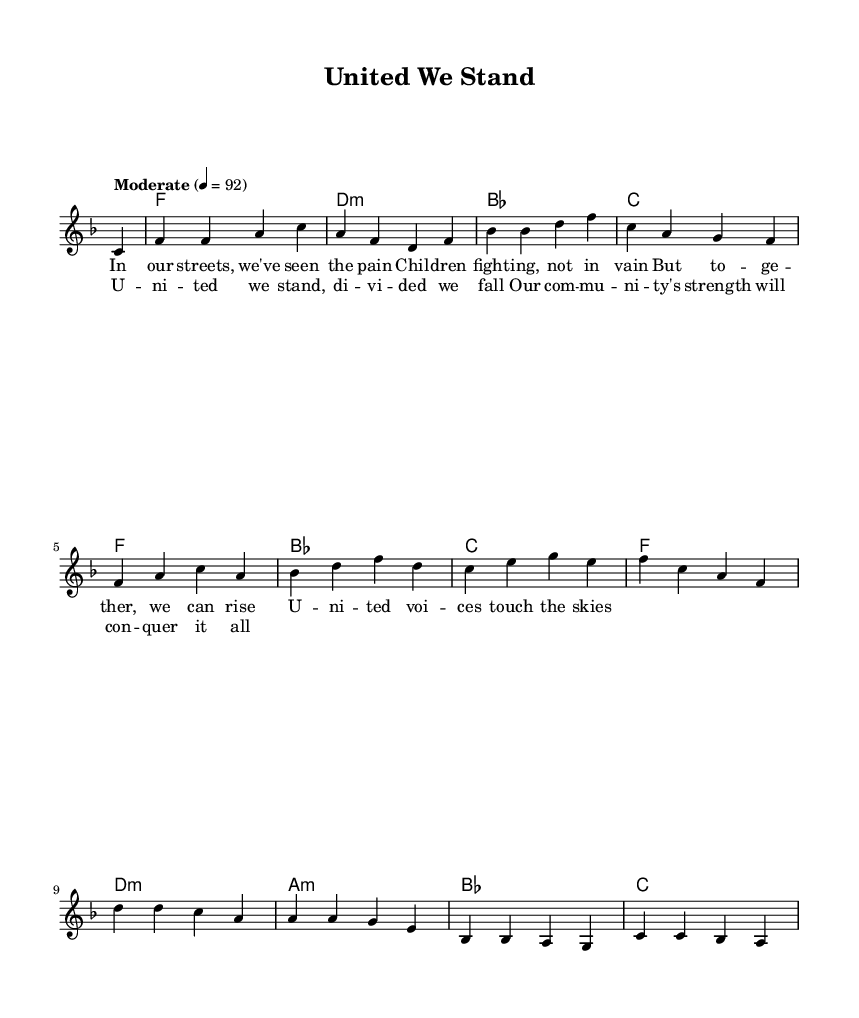What is the key signature of this music? The key signature is F major, which has one flat (B flat). This is evident from the key indication at the beginning of the staff, marked by the 'F' one line above the staff.
Answer: F major What is the time signature of this music? The time signature is 4/4, which signifies that there are four beats in a measure and the quarter note receives one beat. This can be observed at the beginning of the score, next to the key signature.
Answer: 4/4 What is the tempo marking for this piece? The tempo marking is "Moderate," indicated at the start of the score with a metronome marking of 92 beats per minute. This shows the intended pace of the music.
Answer: Moderate How many measures are in the verse section? There are four measures in the verse section, as indicated by the four lines of lyrics. Each line corresponds to one measure, as shown in the melody notation.
Answer: 4 What is the main theme of the chorus lyrics? The main theme of the chorus emphasizes unity and community strength, as highlighted in phrases like "united we stand, divided we fall." This reflects the song's message of togetherness.
Answer: Unity and strength How many chords are used in the harmonies? There are five distinct chords used in the harmonies: F, D minor, B flat, C, and A minor. Each chord appears in the harmonic progression provided.
Answer: 5 What is the overall message conveyed through the lyrics? The overall message conveyed through the lyrics is about resilience and support within the community in the face of struggles, encouraging collective action and solidarity.
Answer: Resilience and support 